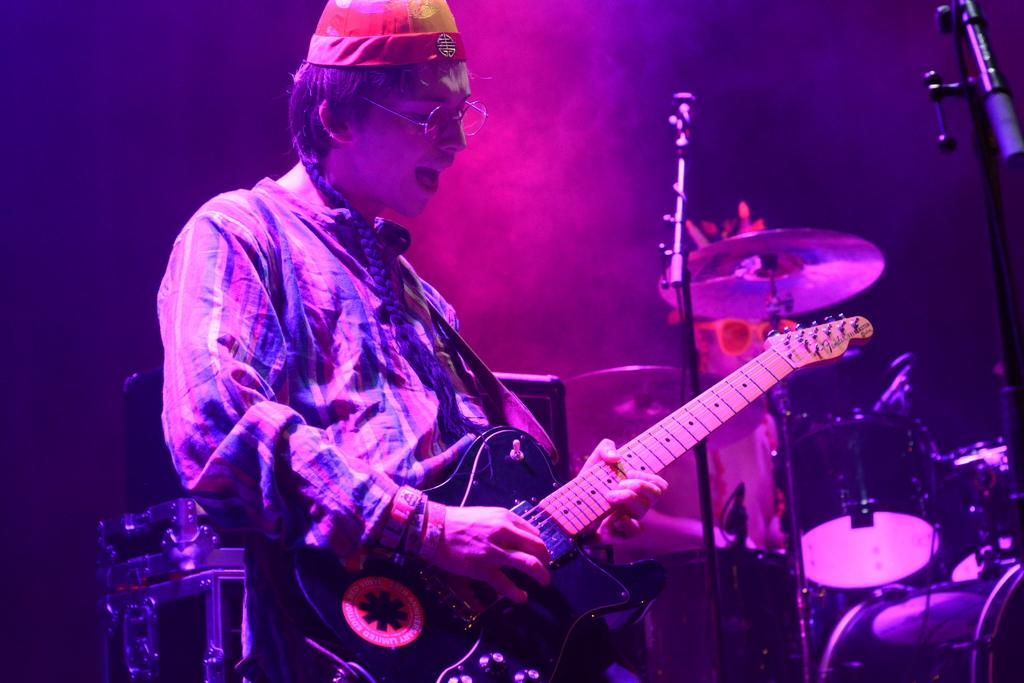What is the main subject of the image? There is a person in the image. What is the person holding in the image? The person is holding a guitar. Can you describe any other objects in the image? There are multiple musical instruments in the image. Can you see any fish swimming in the lake in the image? There is no lake or fish present in the image; it features a person holding a guitar and other musical instruments. 